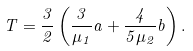<formula> <loc_0><loc_0><loc_500><loc_500>T = \frac { 3 } { 2 } \left ( \frac { 3 } { \mu _ { 1 } } a + \frac { 4 } { 5 \mu _ { 2 } } b \right ) .</formula> 